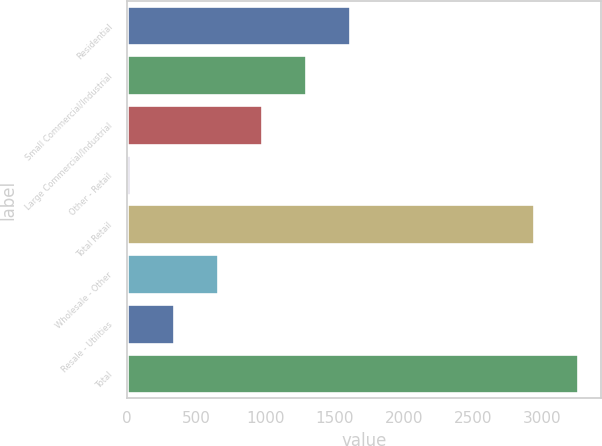Convert chart to OTSL. <chart><loc_0><loc_0><loc_500><loc_500><bar_chart><fcel>Residential<fcel>Small Commercial/Industrial<fcel>Large Commercial/Industrial<fcel>Other - Retail<fcel>Total Retail<fcel>Wholesale - Other<fcel>Resale - Utilities<fcel>Total<nl><fcel>1608.35<fcel>1291.24<fcel>974.13<fcel>22.8<fcel>2944.6<fcel>657.02<fcel>339.91<fcel>3261.71<nl></chart> 